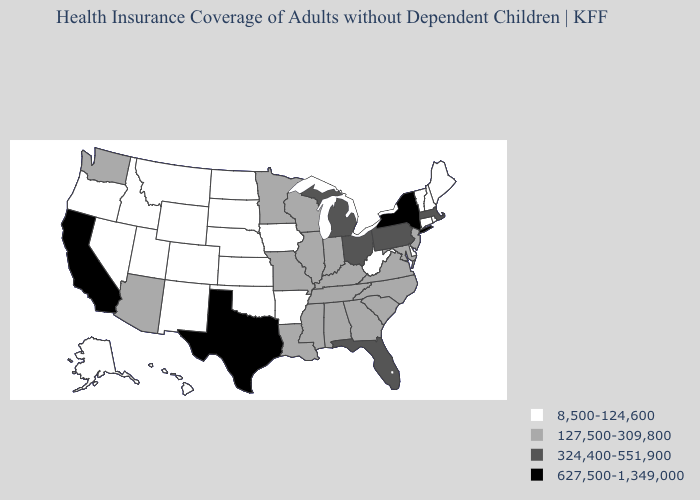What is the value of Arkansas?
Short answer required. 8,500-124,600. What is the lowest value in the USA?
Concise answer only. 8,500-124,600. What is the value of Minnesota?
Be succinct. 127,500-309,800. What is the highest value in states that border South Carolina?
Concise answer only. 127,500-309,800. Name the states that have a value in the range 8,500-124,600?
Quick response, please. Alaska, Arkansas, Colorado, Connecticut, Delaware, Hawaii, Idaho, Iowa, Kansas, Maine, Montana, Nebraska, Nevada, New Hampshire, New Mexico, North Dakota, Oklahoma, Oregon, Rhode Island, South Dakota, Utah, Vermont, West Virginia, Wyoming. Does Missouri have the highest value in the USA?
Write a very short answer. No. What is the value of Wyoming?
Quick response, please. 8,500-124,600. Does West Virginia have a lower value than Michigan?
Quick response, please. Yes. Which states have the highest value in the USA?
Write a very short answer. California, New York, Texas. Among the states that border Nebraska , does Missouri have the lowest value?
Keep it brief. No. What is the value of Louisiana?
Answer briefly. 127,500-309,800. What is the value of Delaware?
Quick response, please. 8,500-124,600. What is the value of Connecticut?
Keep it brief. 8,500-124,600. Name the states that have a value in the range 127,500-309,800?
Concise answer only. Alabama, Arizona, Georgia, Illinois, Indiana, Kentucky, Louisiana, Maryland, Minnesota, Mississippi, Missouri, New Jersey, North Carolina, South Carolina, Tennessee, Virginia, Washington, Wisconsin. Among the states that border Arizona , does California have the lowest value?
Be succinct. No. 